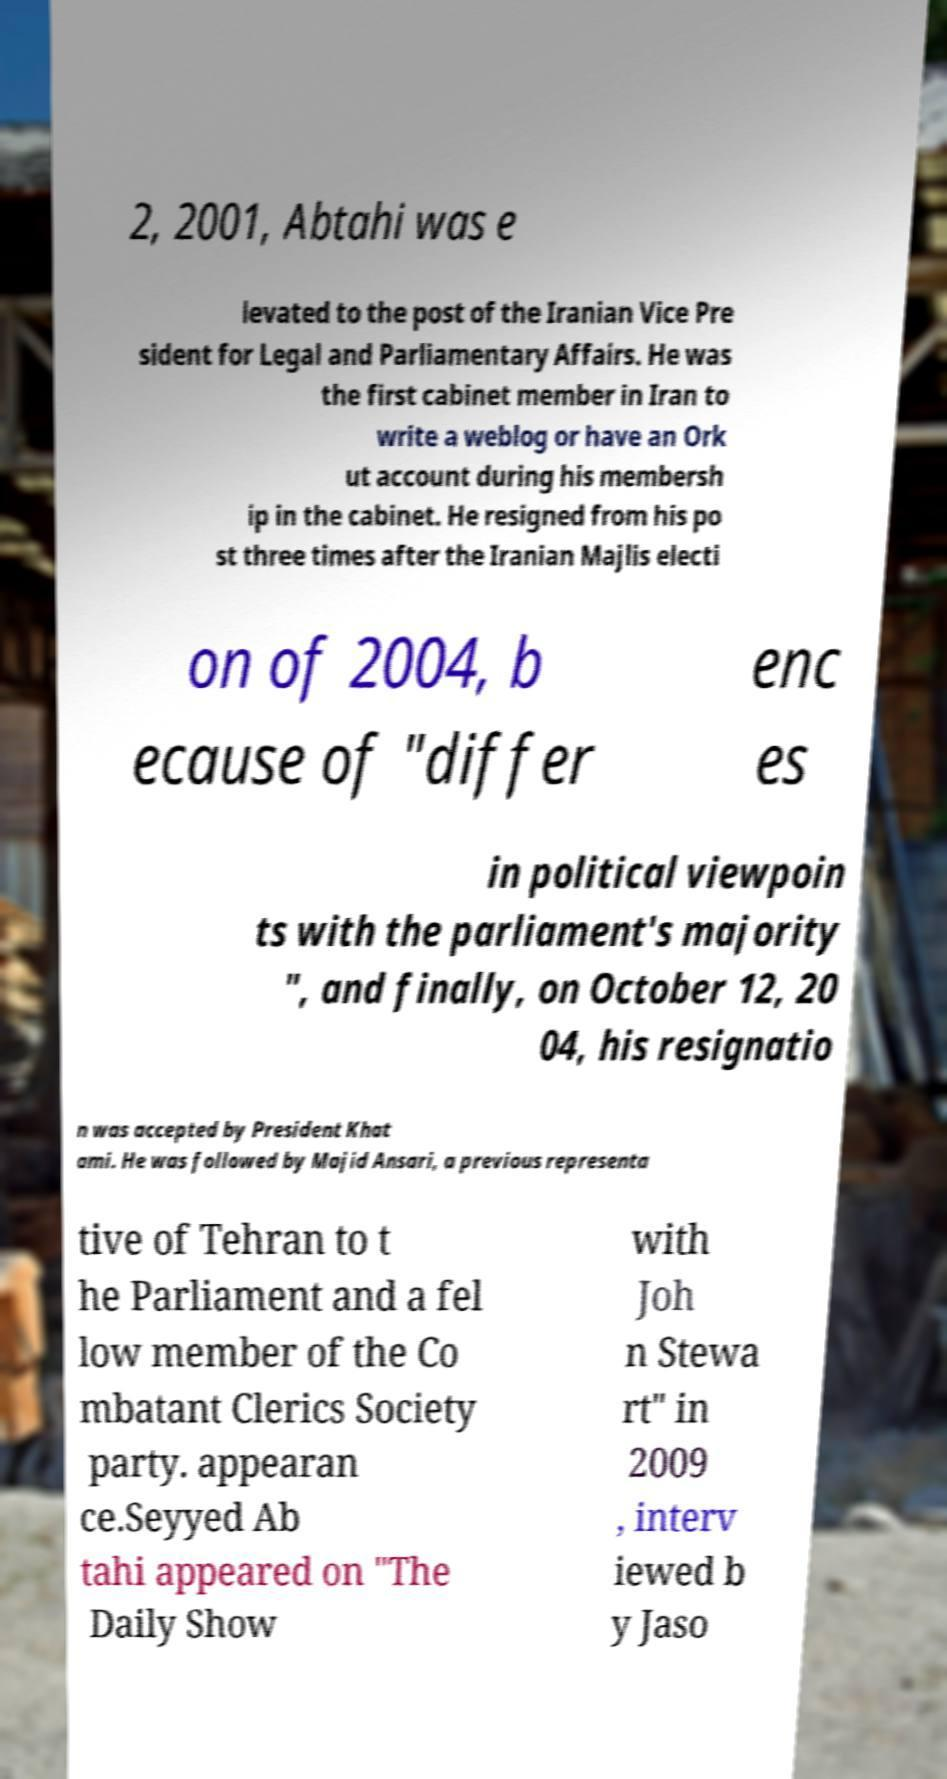Please read and relay the text visible in this image. What does it say? 2, 2001, Abtahi was e levated to the post of the Iranian Vice Pre sident for Legal and Parliamentary Affairs. He was the first cabinet member in Iran to write a weblog or have an Ork ut account during his membersh ip in the cabinet. He resigned from his po st three times after the Iranian Majlis electi on of 2004, b ecause of "differ enc es in political viewpoin ts with the parliament's majority ", and finally, on October 12, 20 04, his resignatio n was accepted by President Khat ami. He was followed by Majid Ansari, a previous representa tive of Tehran to t he Parliament and a fel low member of the Co mbatant Clerics Society party. appearan ce.Seyyed Ab tahi appeared on "The Daily Show with Joh n Stewa rt" in 2009 , interv iewed b y Jaso 